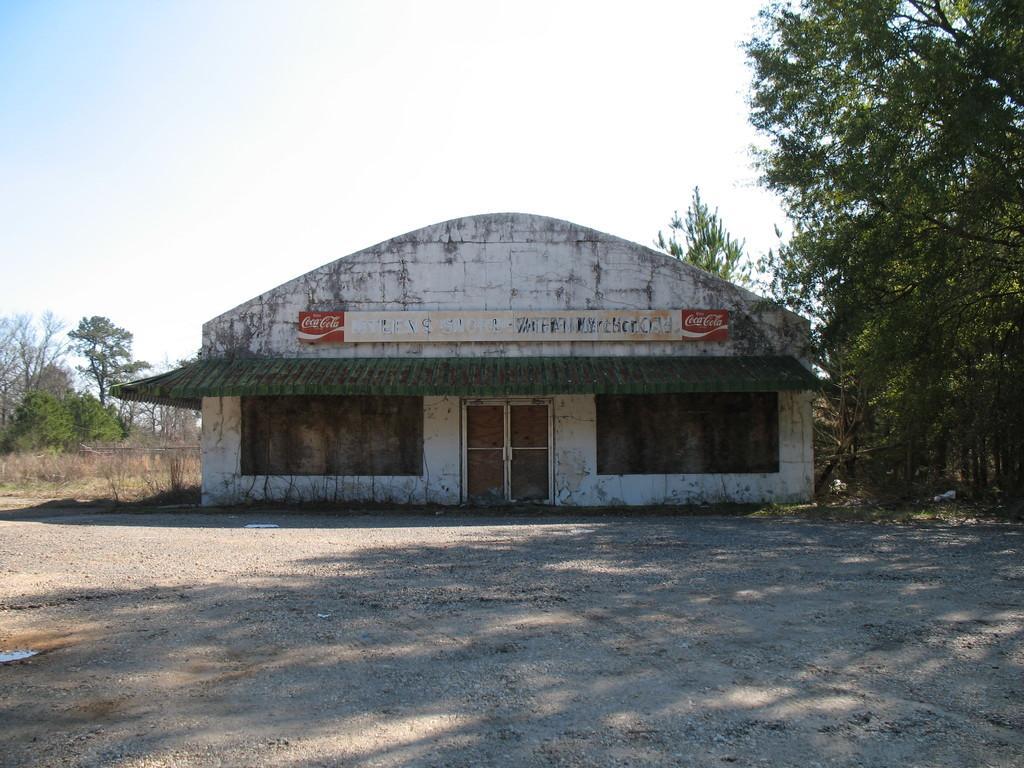Can you describe this image briefly? In this image there is a house in the middle of this image. There is a soil ground in the bottom of this image. There are some trees in the background. There is a sky on the top of this image. 